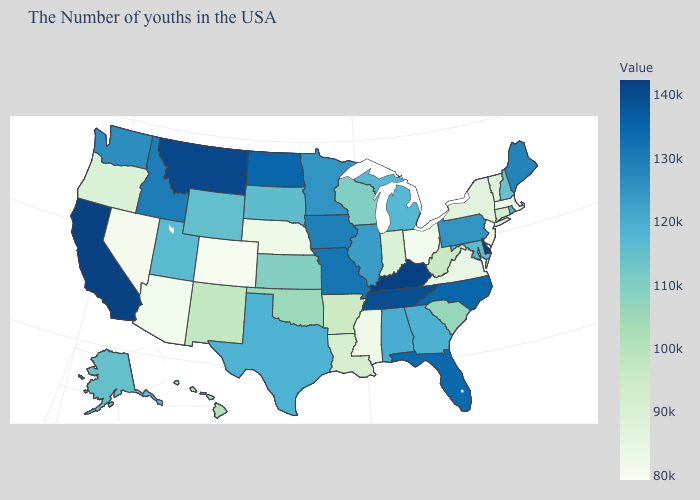Does Mississippi have the lowest value in the South?
Answer briefly. Yes. Is the legend a continuous bar?
Answer briefly. Yes. Among the states that border North Carolina , which have the lowest value?
Answer briefly. Virginia. Which states have the highest value in the USA?
Answer briefly. Delaware. Which states have the lowest value in the USA?
Write a very short answer. Colorado. Does Oregon have a lower value than Florida?
Short answer required. Yes. 